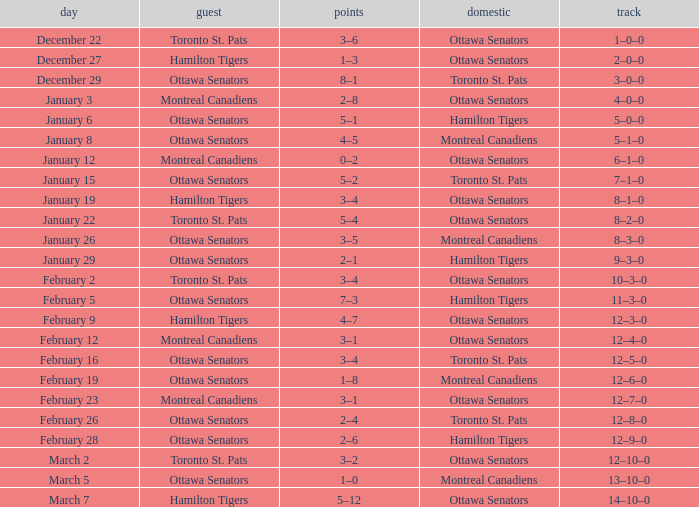Could you parse the entire table? {'header': ['day', 'guest', 'points', 'domestic', 'track'], 'rows': [['December 22', 'Toronto St. Pats', '3–6', 'Ottawa Senators', '1–0–0'], ['December 27', 'Hamilton Tigers', '1–3', 'Ottawa Senators', '2–0–0'], ['December 29', 'Ottawa Senators', '8–1', 'Toronto St. Pats', '3–0–0'], ['January 3', 'Montreal Canadiens', '2–8', 'Ottawa Senators', '4–0–0'], ['January 6', 'Ottawa Senators', '5–1', 'Hamilton Tigers', '5–0–0'], ['January 8', 'Ottawa Senators', '4–5', 'Montreal Canadiens', '5–1–0'], ['January 12', 'Montreal Canadiens', '0–2', 'Ottawa Senators', '6–1–0'], ['January 15', 'Ottawa Senators', '5–2', 'Toronto St. Pats', '7–1–0'], ['January 19', 'Hamilton Tigers', '3–4', 'Ottawa Senators', '8–1–0'], ['January 22', 'Toronto St. Pats', '5–4', 'Ottawa Senators', '8–2–0'], ['January 26', 'Ottawa Senators', '3–5', 'Montreal Canadiens', '8–3–0'], ['January 29', 'Ottawa Senators', '2–1', 'Hamilton Tigers', '9–3–0'], ['February 2', 'Toronto St. Pats', '3–4', 'Ottawa Senators', '10–3–0'], ['February 5', 'Ottawa Senators', '7–3', 'Hamilton Tigers', '11–3–0'], ['February 9', 'Hamilton Tigers', '4–7', 'Ottawa Senators', '12–3–0'], ['February 12', 'Montreal Canadiens', '3–1', 'Ottawa Senators', '12–4–0'], ['February 16', 'Ottawa Senators', '3–4', 'Toronto St. Pats', '12–5–0'], ['February 19', 'Ottawa Senators', '1–8', 'Montreal Canadiens', '12–6–0'], ['February 23', 'Montreal Canadiens', '3–1', 'Ottawa Senators', '12–7–0'], ['February 26', 'Ottawa Senators', '2–4', 'Toronto St. Pats', '12–8–0'], ['February 28', 'Ottawa Senators', '2–6', 'Hamilton Tigers', '12–9–0'], ['March 2', 'Toronto St. Pats', '3–2', 'Ottawa Senators', '12–10–0'], ['March 5', 'Ottawa Senators', '1–0', 'Montreal Canadiens', '13–10–0'], ['March 7', 'Hamilton Tigers', '5–12', 'Ottawa Senators', '14–10–0']]} What is the record for the game on January 19? 8–1–0. 